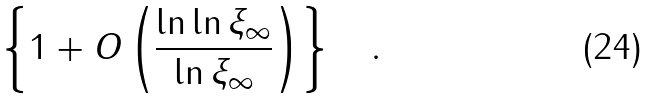Convert formula to latex. <formula><loc_0><loc_0><loc_500><loc_500>\left \{ 1 + O \left ( \frac { \ln { \ln { \xi _ { \infty } } } } { \ln { \xi _ { \infty } } } \right ) \right \} \quad .</formula> 